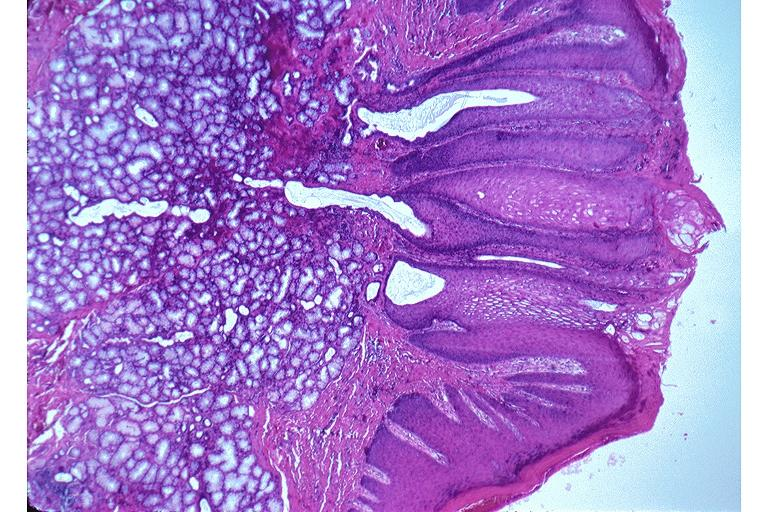what does this image show?
Answer the question using a single word or phrase. Nicotine stomatitis 